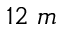Convert formula to latex. <formula><loc_0><loc_0><loc_500><loc_500>1 2 m</formula> 